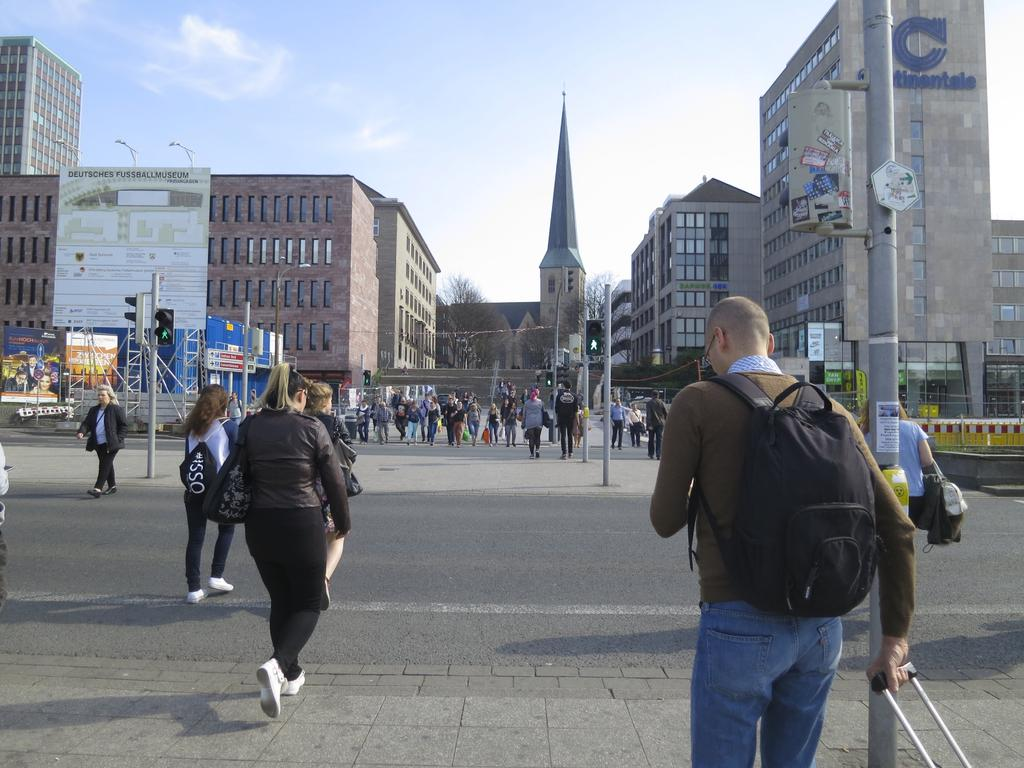Who or what is present in the image? There are people in the image. What is in the center of the image? There is a road in the center of the image. What structures can be seen in the image? There are poles and a traffic light on the left side of the image, as well as buildings in the background. What else can be seen in the background of the image? There are trees and the sky visible in the background of the image. How many apples are being used as a notebook in the image? There are no apples or notebooks present in the image. What type of roof is visible on the buildings in the image? The image does not show the roofs of the buildings, only their facades. 